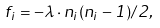<formula> <loc_0><loc_0><loc_500><loc_500>f _ { i } = - \lambda \cdot n _ { i } ( n _ { i } - 1 ) / 2 ,</formula> 